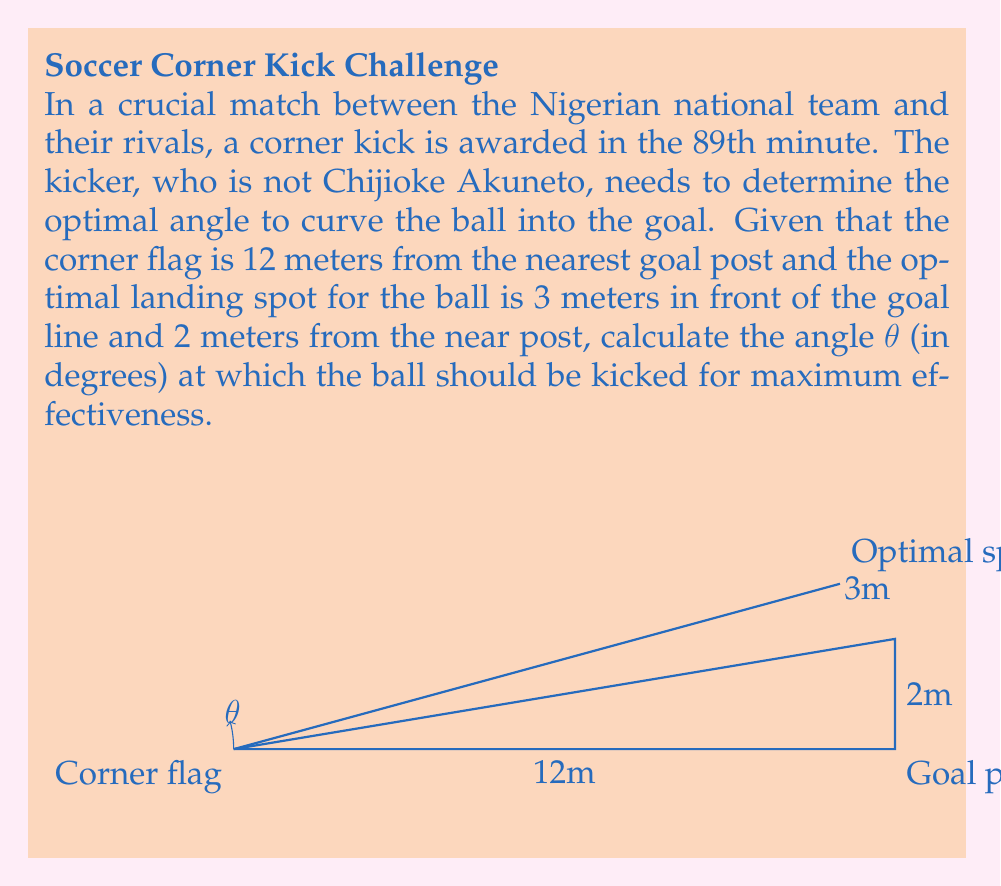Help me with this question. Let's approach this step-by-step using trigonometric functions:

1) First, we need to determine the coordinates of our points. Let's set the corner flag as the origin (0,0).
   - Corner flag: (0,0)
   - Goal post: (12,0)
   - Optimal landing spot: (10,2)

2) We can create a right triangle with the corner flag, the goal post, and the optimal landing spot.

3) The angle we're looking for is between the line from the corner flag to the goal post and the line from the corner flag to the optimal landing spot.

4) We can use the arctangent function to find this angle. The arctangent of the opposite side over the adjacent side will give us the angle in radians.

5) In this case:
   - Opposite side = 2 (the y-coordinate of the optimal spot)
   - Adjacent side = 10 (the x-coordinate of the optimal spot)

6) Let's calculate:
   $$θ = \arctan(\frac{2}{10})$$

7) Using a calculator or computer:
   $$θ ≈ 0.1973955 \text{ radians}$$

8) To convert to degrees, we multiply by (180/π):
   $$θ ≈ 0.1973955 * \frac{180}{\pi} ≈ 11.3099325°$$

9) Rounding to two decimal places:
   $$θ ≈ 11.31°$$

Therefore, the optimal angle for the corner kick is approximately 11.31 degrees.
Answer: $11.31°$ 